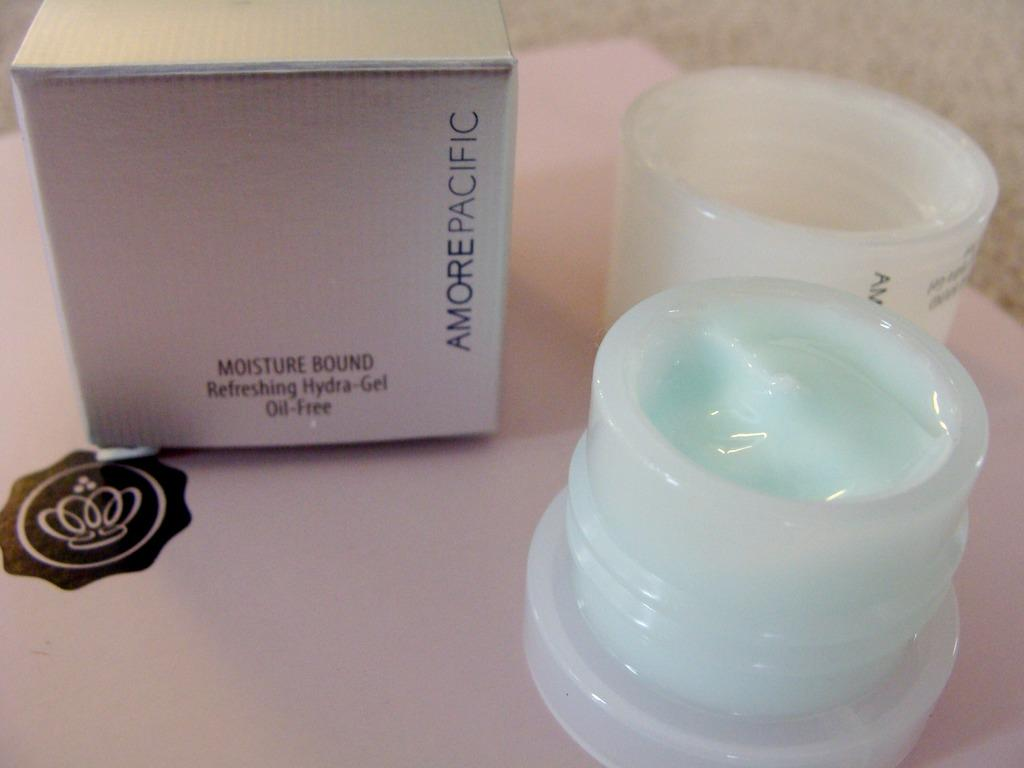<image>
Relay a brief, clear account of the picture shown. A product is lifted as Oil-Free and being a Refreshing Hydra-Gel. 